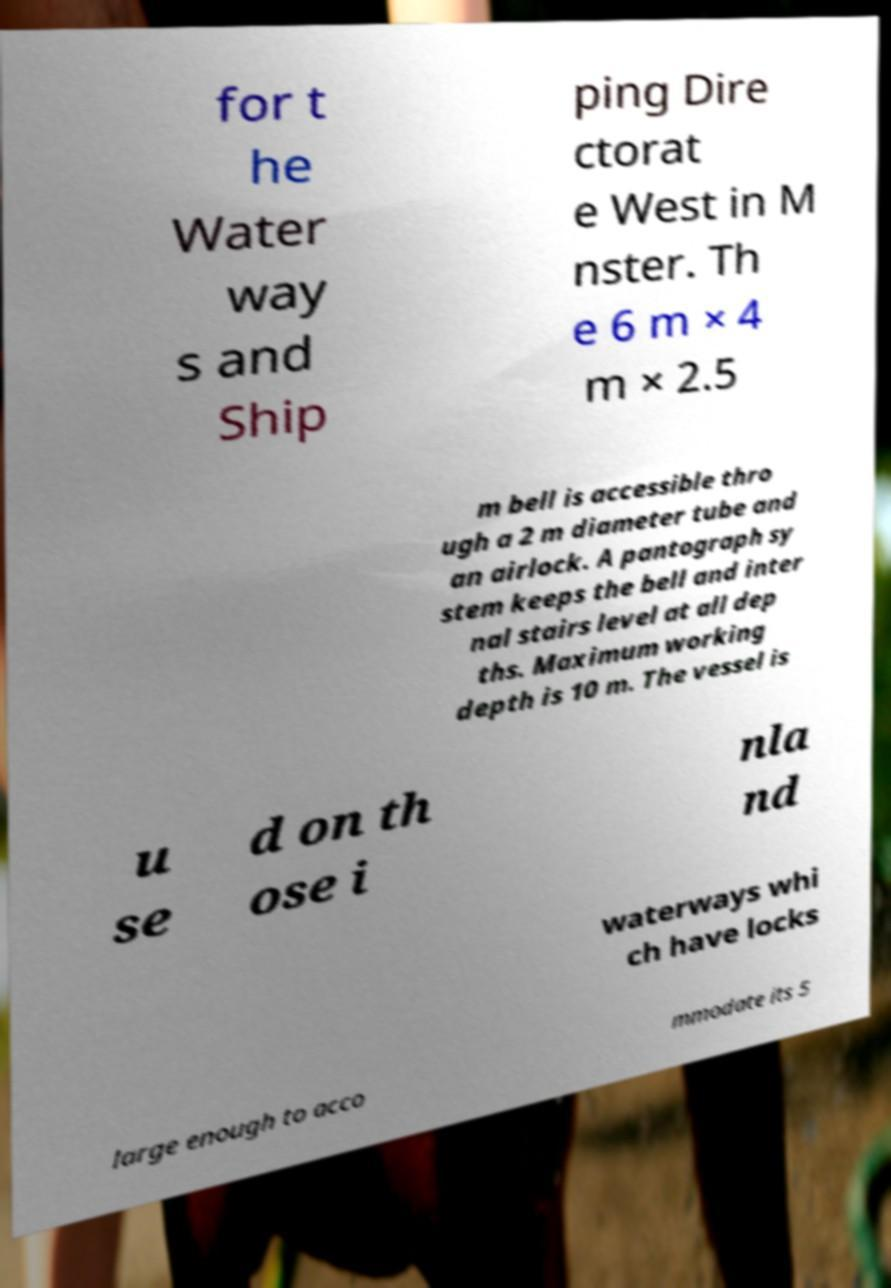Can you read and provide the text displayed in the image?This photo seems to have some interesting text. Can you extract and type it out for me? for t he Water way s and Ship ping Dire ctorat e West in M nster. Th e 6 m × 4 m × 2.5 m bell is accessible thro ugh a 2 m diameter tube and an airlock. A pantograph sy stem keeps the bell and inter nal stairs level at all dep ths. Maximum working depth is 10 m. The vessel is u se d on th ose i nla nd waterways whi ch have locks large enough to acco mmodate its 5 